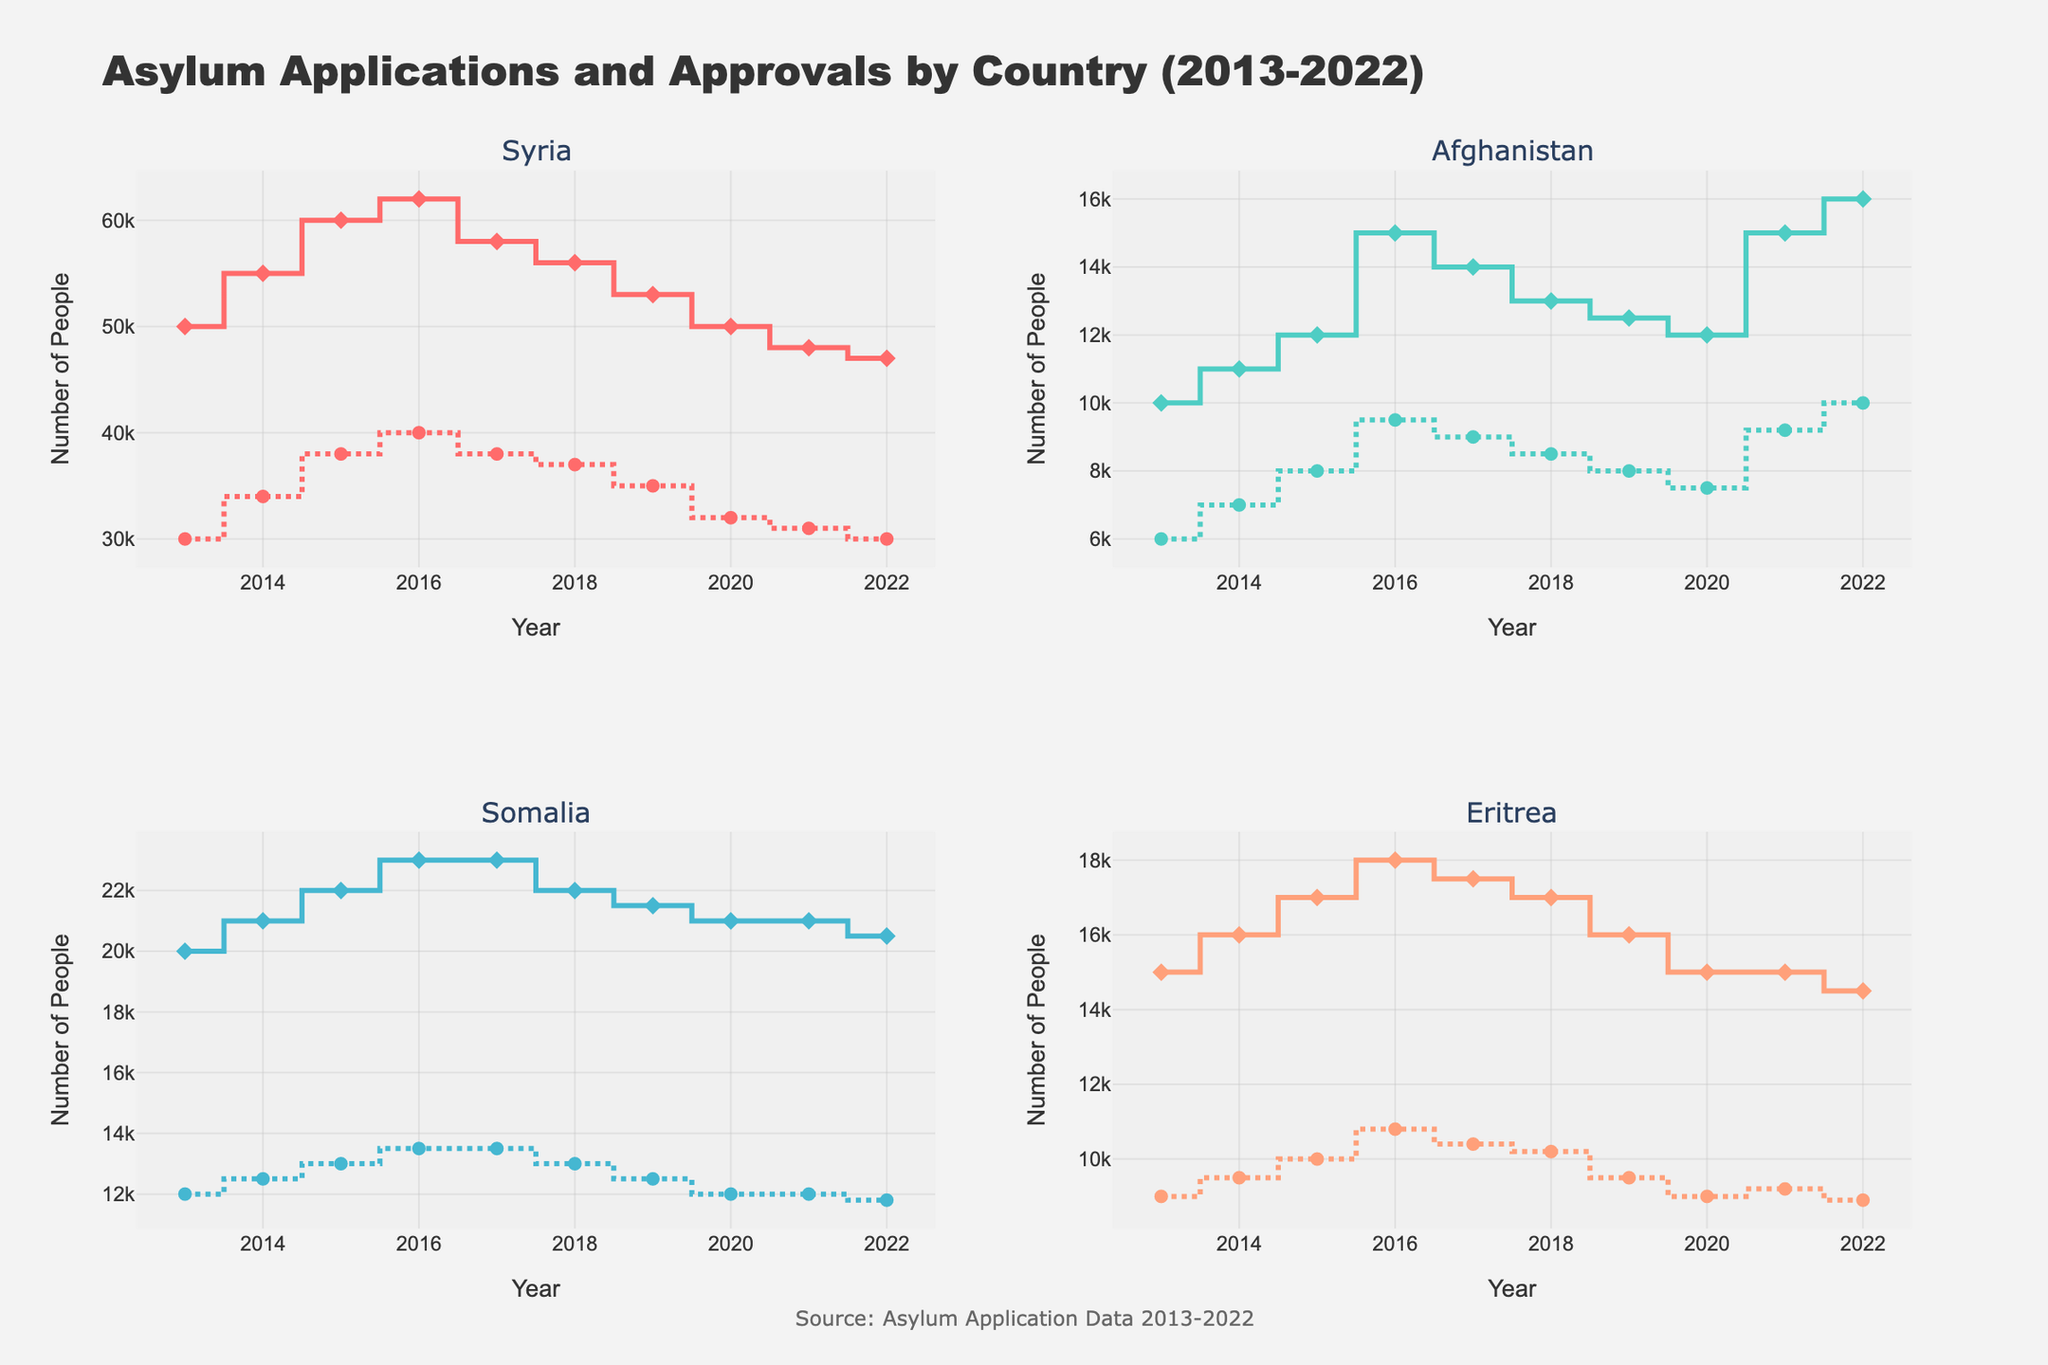Which country has the highest number of asylum approvals in 2016? Look at the 'approvals' data points for 2016 across all countries in the figure. Syria has 40,000 approvals in 2016, the highest compared to Afghanistan, Somalia, and Eritrea.
Answer: Syria How many applications and approvals did Eritrea receive in 2020? Check the 'applications' and 'approvals' data points for Eritrea in 2020. Eritrea received 15,000 applications and 9,000 approvals.
Answer: 15,000 applications, 9,000 approvals What's the trend of asylum applications for Afghanistan from 2013 to 2022? Trace the 'applications' line for Afghanistan from 2013 to 2022. The trend shows an initial increase until 2016, then fluctuates slightly afterwards, with a notable increase again in 2021 and 2022.
Answer: Increasing with fluctuations Compare the number of approvals for Syria and Somalia in 2015. Look at the 'approvals' data points for Syria and Somalia in 2015. Syria has 38,000 approvals and Somalia has 13,000 approvals in 2015.
Answer: Syria has more approvals Which country had the highest decline in approvals from 2016 to 2022? Observe the change in 'approvals' from 2016 to 2022 for each country. Syria declines from 40,000 to 30,000, the highest decline compared to the other countries.
Answer: Syria For which year does Somalia have the same number of applications as Eritrea's approvals? Find the point where Somalia's 'applications' match Eritrea's 'approvals'. In 2013, Somalia's applications (20,000) match Eritrea's approvals (20,000).
Answer: 2013 Calculate the average number of applications for Somalia between 2013 and 2022. Sum Somalia's 'applications' from 2013 to 2022 and divide by the number of years. (20,000 + 21,000 + 22,000 + 23,000 + 23,000 + 22,000 + 21,500 + 21,000 + 21,000 + 20,500) / 10 = 21,200
Answer: 21,200 Which country has the lowest number of approvals in 2019? Compare the 'approvals' data points for 2019 across all countries. Afghanistan has the lowest with 8,000 approvals.
Answer: Afghanistan In which year did Afghanistan see the highest number of approvals? Look for Afghanistan's 'approvals' data point with the maximum value. The highest number of approvals is 10,000 in 2022.
Answer: 2022 How much did the number of applications for Syria decrease from 2016 to 2022? Subtract the number of 'applications' for Syria in 2022 from the number in 2016. 62,000 (2016) - 47,000 (2022) = 15,000
Answer: 15,000 